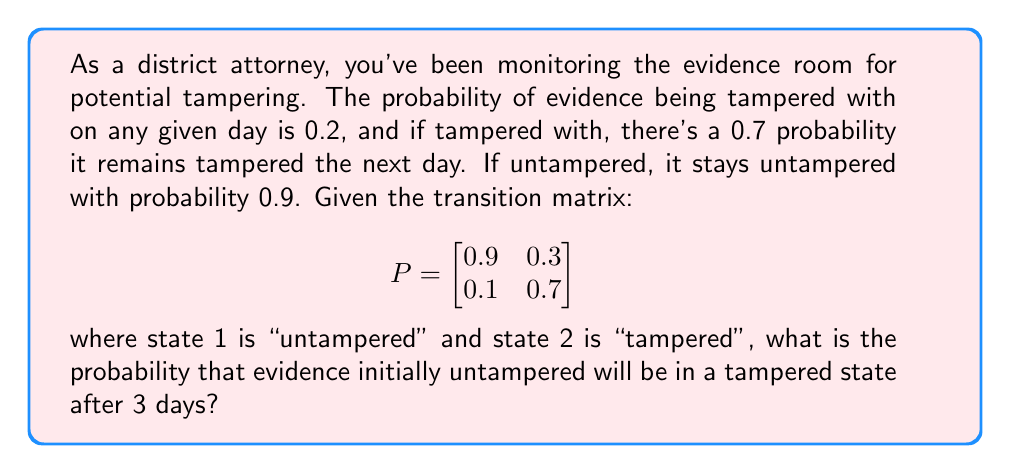Could you help me with this problem? Let's approach this step-by-step:

1) We start with the initial state vector. Since the evidence is initially untampered, our initial state vector is:

   $$v_0 = \begin{bmatrix} 1 \\ 0 \end{bmatrix}$$

2) To find the state after 3 days, we need to multiply the initial state vector by the transition matrix raised to the power of 3:

   $$v_3 = P^3 \cdot v_0$$

3) Let's calculate $P^3$:

   $$P^2 = \begin{bmatrix}
   0.9 & 0.3 \\
   0.1 & 0.7
   \end{bmatrix} \cdot \begin{bmatrix}
   0.9 & 0.3 \\
   0.1 & 0.7
   \end{bmatrix} = \begin{bmatrix}
   0.84 & 0.48 \\
   0.16 & 0.52
   \end{bmatrix}$$

   $$P^3 = P \cdot P^2 = \begin{bmatrix}
   0.9 & 0.3 \\
   0.1 & 0.7
   \end{bmatrix} \cdot \begin{bmatrix}
   0.84 & 0.48 \\
   0.16 & 0.52
   \end{bmatrix} = \begin{bmatrix}
   0.804 & 0.588 \\
   0.196 & 0.412
   \end{bmatrix}$$

4) Now, we multiply $P^3$ by the initial state vector:

   $$v_3 = P^3 \cdot v_0 = \begin{bmatrix}
   0.804 & 0.588 \\
   0.196 & 0.412
   \end{bmatrix} \cdot \begin{bmatrix}
   1 \\
   0
   \end{bmatrix} = \begin{bmatrix}
   0.804 \\
   0.196
   \end{bmatrix}$$

5) The second element of this resulting vector (0.196) represents the probability of the evidence being in a tampered state after 3 days.
Answer: 0.196 